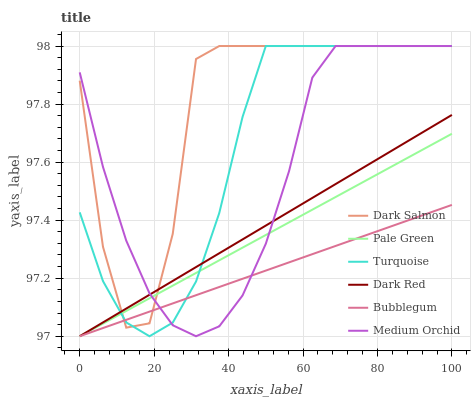Does Bubblegum have the minimum area under the curve?
Answer yes or no. Yes. Does Dark Salmon have the maximum area under the curve?
Answer yes or no. Yes. Does Dark Red have the minimum area under the curve?
Answer yes or no. No. Does Dark Red have the maximum area under the curve?
Answer yes or no. No. Is Dark Red the smoothest?
Answer yes or no. Yes. Is Dark Salmon the roughest?
Answer yes or no. Yes. Is Medium Orchid the smoothest?
Answer yes or no. No. Is Medium Orchid the roughest?
Answer yes or no. No. Does Dark Red have the lowest value?
Answer yes or no. Yes. Does Medium Orchid have the lowest value?
Answer yes or no. No. Does Dark Salmon have the highest value?
Answer yes or no. Yes. Does Dark Red have the highest value?
Answer yes or no. No. Does Medium Orchid intersect Dark Salmon?
Answer yes or no. Yes. Is Medium Orchid less than Dark Salmon?
Answer yes or no. No. Is Medium Orchid greater than Dark Salmon?
Answer yes or no. No. 